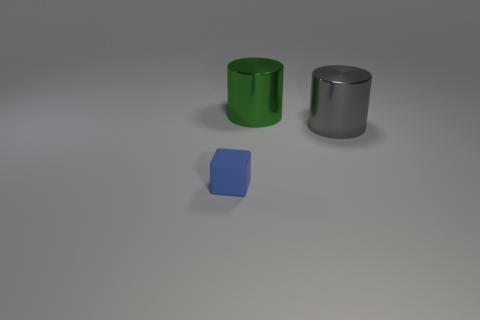Are there any tiny rubber blocks right of the big gray metallic cylinder?
Provide a short and direct response. No. There is a thing that is in front of the large cylinder that is right of the big cylinder that is to the left of the large gray shiny cylinder; what color is it?
Your answer should be compact. Blue. Does the gray thing have the same shape as the tiny blue matte object?
Ensure brevity in your answer.  No. The object that is made of the same material as the large gray cylinder is what color?
Give a very brief answer. Green. How many things are either things that are on the right side of the small blue rubber block or blue cubes?
Your response must be concise. 3. How big is the shiny object that is to the left of the large gray thing?
Offer a very short reply. Large. There is a green shiny object; does it have the same size as the shiny cylinder that is in front of the green thing?
Offer a terse response. Yes. What color is the big metallic cylinder that is left of the large metal thing on the right side of the big green metallic object?
Your answer should be very brief. Green. What number of other things are the same color as the tiny rubber object?
Make the answer very short. 0. What is the size of the green cylinder?
Offer a very short reply. Large. 